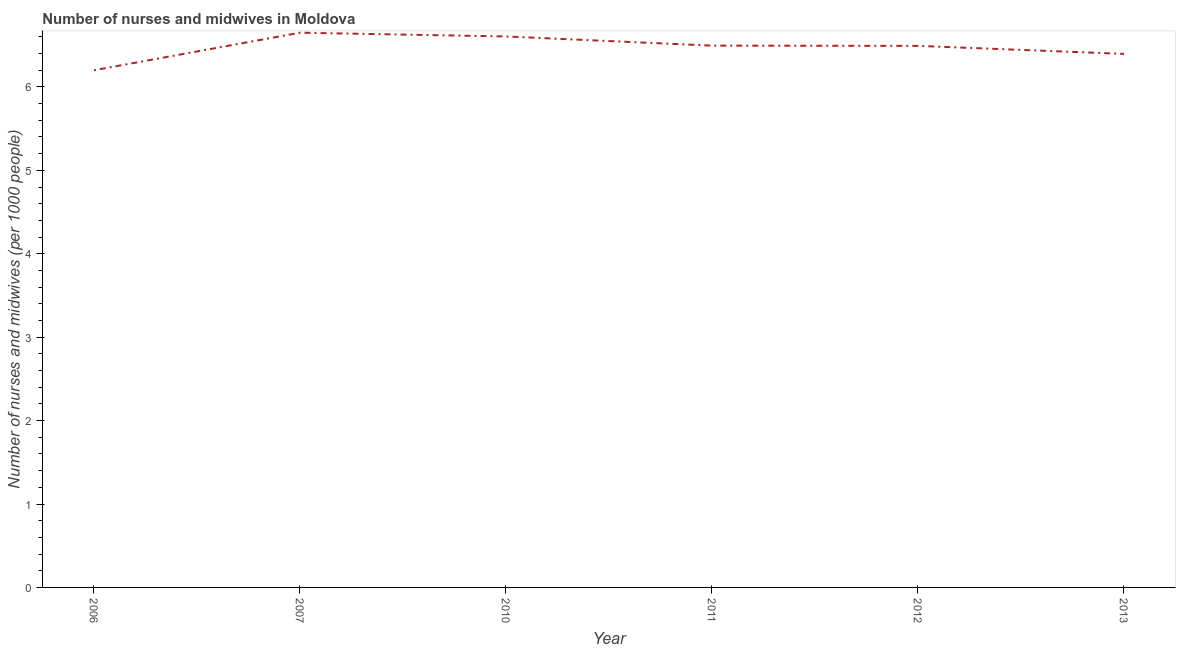What is the number of nurses and midwives in 2007?
Provide a succinct answer. 6.65. Across all years, what is the maximum number of nurses and midwives?
Your answer should be compact. 6.65. Across all years, what is the minimum number of nurses and midwives?
Offer a very short reply. 6.2. In which year was the number of nurses and midwives minimum?
Make the answer very short. 2006. What is the sum of the number of nurses and midwives?
Offer a very short reply. 38.84. What is the difference between the number of nurses and midwives in 2011 and 2012?
Provide a succinct answer. 0. What is the average number of nurses and midwives per year?
Your answer should be compact. 6.47. What is the median number of nurses and midwives?
Your response must be concise. 6.49. In how many years, is the number of nurses and midwives greater than 4 ?
Your response must be concise. 6. Do a majority of the years between 2013 and 2012 (inclusive) have number of nurses and midwives greater than 5.4 ?
Your response must be concise. No. What is the ratio of the number of nurses and midwives in 2007 to that in 2013?
Offer a very short reply. 1.04. Is the number of nurses and midwives in 2010 less than that in 2013?
Provide a short and direct response. No. Is the difference between the number of nurses and midwives in 2006 and 2007 greater than the difference between any two years?
Your response must be concise. Yes. What is the difference between the highest and the second highest number of nurses and midwives?
Keep it short and to the point. 0.04. What is the difference between the highest and the lowest number of nurses and midwives?
Make the answer very short. 0.45. In how many years, is the number of nurses and midwives greater than the average number of nurses and midwives taken over all years?
Keep it short and to the point. 4. Does the number of nurses and midwives monotonically increase over the years?
Your response must be concise. No. Are the values on the major ticks of Y-axis written in scientific E-notation?
Give a very brief answer. No. Does the graph contain any zero values?
Provide a succinct answer. No. Does the graph contain grids?
Provide a succinct answer. No. What is the title of the graph?
Make the answer very short. Number of nurses and midwives in Moldova. What is the label or title of the X-axis?
Keep it short and to the point. Year. What is the label or title of the Y-axis?
Keep it short and to the point. Number of nurses and midwives (per 1000 people). What is the Number of nurses and midwives (per 1000 people) in 2007?
Provide a short and direct response. 6.65. What is the Number of nurses and midwives (per 1000 people) in 2010?
Provide a short and direct response. 6.61. What is the Number of nurses and midwives (per 1000 people) of 2011?
Offer a terse response. 6.5. What is the Number of nurses and midwives (per 1000 people) in 2012?
Provide a succinct answer. 6.49. What is the Number of nurses and midwives (per 1000 people) in 2013?
Make the answer very short. 6.4. What is the difference between the Number of nurses and midwives (per 1000 people) in 2006 and 2007?
Make the answer very short. -0.45. What is the difference between the Number of nurses and midwives (per 1000 people) in 2006 and 2010?
Your response must be concise. -0.41. What is the difference between the Number of nurses and midwives (per 1000 people) in 2006 and 2011?
Provide a succinct answer. -0.29. What is the difference between the Number of nurses and midwives (per 1000 people) in 2006 and 2012?
Provide a short and direct response. -0.29. What is the difference between the Number of nurses and midwives (per 1000 people) in 2006 and 2013?
Make the answer very short. -0.2. What is the difference between the Number of nurses and midwives (per 1000 people) in 2007 and 2010?
Your answer should be very brief. 0.04. What is the difference between the Number of nurses and midwives (per 1000 people) in 2007 and 2011?
Your answer should be very brief. 0.15. What is the difference between the Number of nurses and midwives (per 1000 people) in 2007 and 2012?
Offer a terse response. 0.16. What is the difference between the Number of nurses and midwives (per 1000 people) in 2007 and 2013?
Keep it short and to the point. 0.25. What is the difference between the Number of nurses and midwives (per 1000 people) in 2010 and 2011?
Your answer should be very brief. 0.11. What is the difference between the Number of nurses and midwives (per 1000 people) in 2010 and 2012?
Provide a succinct answer. 0.11. What is the difference between the Number of nurses and midwives (per 1000 people) in 2010 and 2013?
Provide a short and direct response. 0.21. What is the difference between the Number of nurses and midwives (per 1000 people) in 2011 and 2012?
Offer a terse response. 0. What is the difference between the Number of nurses and midwives (per 1000 people) in 2011 and 2013?
Offer a very short reply. 0.1. What is the difference between the Number of nurses and midwives (per 1000 people) in 2012 and 2013?
Your answer should be compact. 0.1. What is the ratio of the Number of nurses and midwives (per 1000 people) in 2006 to that in 2007?
Your answer should be very brief. 0.93. What is the ratio of the Number of nurses and midwives (per 1000 people) in 2006 to that in 2010?
Your answer should be very brief. 0.94. What is the ratio of the Number of nurses and midwives (per 1000 people) in 2006 to that in 2011?
Your answer should be very brief. 0.95. What is the ratio of the Number of nurses and midwives (per 1000 people) in 2006 to that in 2012?
Provide a succinct answer. 0.95. What is the ratio of the Number of nurses and midwives (per 1000 people) in 2007 to that in 2013?
Give a very brief answer. 1.04. What is the ratio of the Number of nurses and midwives (per 1000 people) in 2010 to that in 2013?
Offer a very short reply. 1.03. What is the ratio of the Number of nurses and midwives (per 1000 people) in 2011 to that in 2012?
Your response must be concise. 1. What is the ratio of the Number of nurses and midwives (per 1000 people) in 2011 to that in 2013?
Provide a succinct answer. 1.01. 